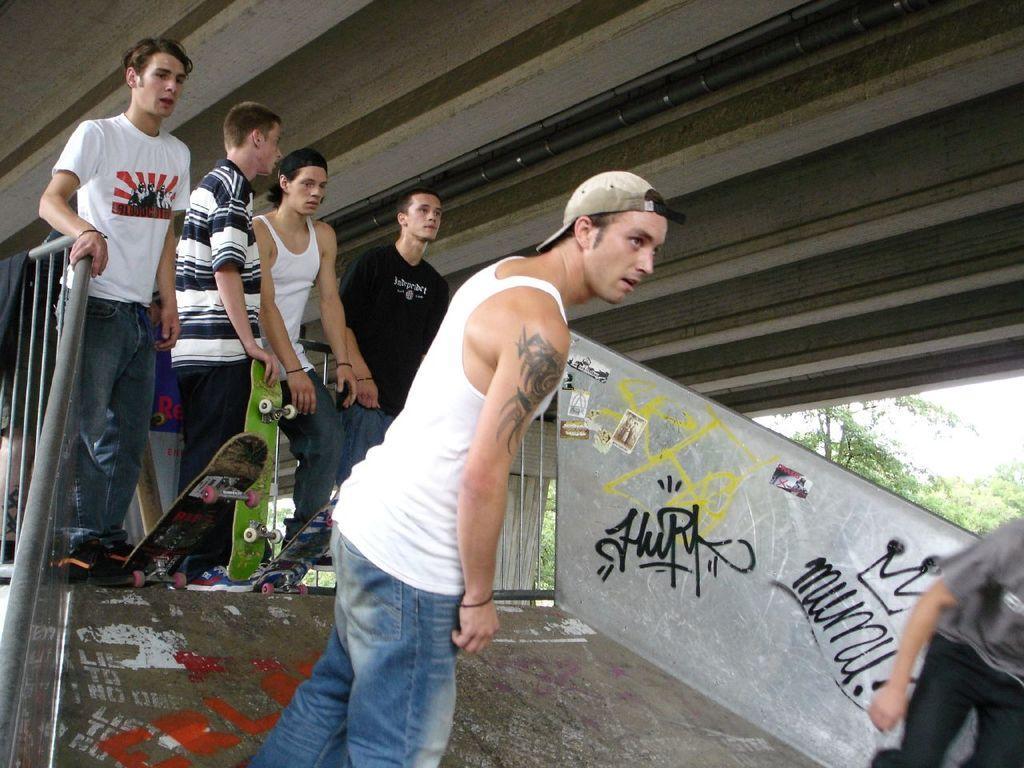Could you give a brief overview of what you see in this image? In this image there is a metal railing on the left corner. There is a ramp at the bottom. There are people and skateboards in the foreground. There is a person and there are trees on the right corner. There is roof at the top. 